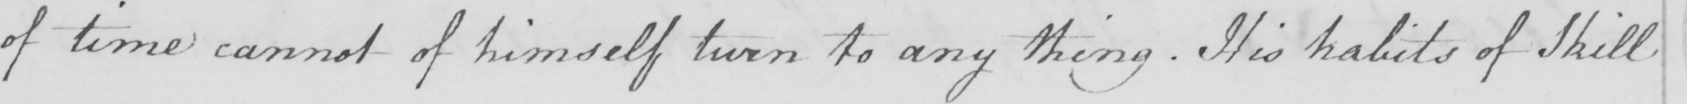Transcribe the text shown in this historical manuscript line. of time cannot of himself turn to any thing . His habits of Skill 